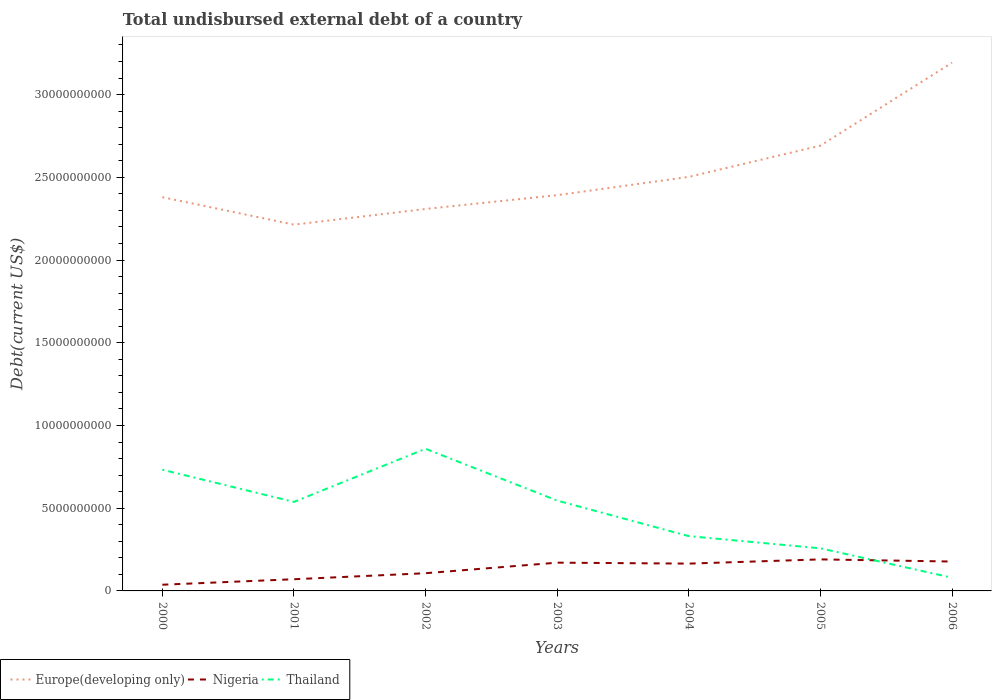Does the line corresponding to Nigeria intersect with the line corresponding to Europe(developing only)?
Your answer should be compact. No. Across all years, what is the maximum total undisbursed external debt in Thailand?
Your answer should be compact. 8.01e+08. In which year was the total undisbursed external debt in Nigeria maximum?
Your answer should be very brief. 2000. What is the total total undisbursed external debt in Nigeria in the graph?
Give a very brief answer. 1.30e+08. What is the difference between the highest and the second highest total undisbursed external debt in Nigeria?
Provide a succinct answer. 1.53e+09. How many years are there in the graph?
Offer a very short reply. 7. Are the values on the major ticks of Y-axis written in scientific E-notation?
Provide a succinct answer. No. Where does the legend appear in the graph?
Offer a very short reply. Bottom left. What is the title of the graph?
Ensure brevity in your answer.  Total undisbursed external debt of a country. What is the label or title of the X-axis?
Give a very brief answer. Years. What is the label or title of the Y-axis?
Your response must be concise. Debt(current US$). What is the Debt(current US$) in Europe(developing only) in 2000?
Provide a short and direct response. 2.38e+1. What is the Debt(current US$) of Nigeria in 2000?
Your response must be concise. 3.75e+08. What is the Debt(current US$) in Thailand in 2000?
Your answer should be very brief. 7.33e+09. What is the Debt(current US$) in Europe(developing only) in 2001?
Provide a succinct answer. 2.21e+1. What is the Debt(current US$) of Nigeria in 2001?
Ensure brevity in your answer.  7.07e+08. What is the Debt(current US$) in Thailand in 2001?
Your answer should be compact. 5.38e+09. What is the Debt(current US$) of Europe(developing only) in 2002?
Your answer should be compact. 2.31e+1. What is the Debt(current US$) in Nigeria in 2002?
Provide a succinct answer. 1.07e+09. What is the Debt(current US$) of Thailand in 2002?
Give a very brief answer. 8.59e+09. What is the Debt(current US$) in Europe(developing only) in 2003?
Ensure brevity in your answer.  2.39e+1. What is the Debt(current US$) in Nigeria in 2003?
Keep it short and to the point. 1.71e+09. What is the Debt(current US$) in Thailand in 2003?
Offer a terse response. 5.46e+09. What is the Debt(current US$) of Europe(developing only) in 2004?
Provide a succinct answer. 2.50e+1. What is the Debt(current US$) in Nigeria in 2004?
Provide a succinct answer. 1.65e+09. What is the Debt(current US$) of Thailand in 2004?
Offer a very short reply. 3.31e+09. What is the Debt(current US$) of Europe(developing only) in 2005?
Offer a very short reply. 2.69e+1. What is the Debt(current US$) in Nigeria in 2005?
Your answer should be very brief. 1.91e+09. What is the Debt(current US$) of Thailand in 2005?
Ensure brevity in your answer.  2.58e+09. What is the Debt(current US$) of Europe(developing only) in 2006?
Provide a succinct answer. 3.19e+1. What is the Debt(current US$) in Nigeria in 2006?
Provide a succinct answer. 1.78e+09. What is the Debt(current US$) in Thailand in 2006?
Provide a short and direct response. 8.01e+08. Across all years, what is the maximum Debt(current US$) in Europe(developing only)?
Your answer should be very brief. 3.19e+1. Across all years, what is the maximum Debt(current US$) in Nigeria?
Give a very brief answer. 1.91e+09. Across all years, what is the maximum Debt(current US$) of Thailand?
Your answer should be very brief. 8.59e+09. Across all years, what is the minimum Debt(current US$) in Europe(developing only)?
Give a very brief answer. 2.21e+1. Across all years, what is the minimum Debt(current US$) of Nigeria?
Keep it short and to the point. 3.75e+08. Across all years, what is the minimum Debt(current US$) in Thailand?
Your answer should be compact. 8.01e+08. What is the total Debt(current US$) of Europe(developing only) in the graph?
Your answer should be compact. 1.77e+11. What is the total Debt(current US$) of Nigeria in the graph?
Ensure brevity in your answer.  9.19e+09. What is the total Debt(current US$) of Thailand in the graph?
Make the answer very short. 3.34e+1. What is the difference between the Debt(current US$) of Europe(developing only) in 2000 and that in 2001?
Provide a short and direct response. 1.66e+09. What is the difference between the Debt(current US$) in Nigeria in 2000 and that in 2001?
Ensure brevity in your answer.  -3.31e+08. What is the difference between the Debt(current US$) of Thailand in 2000 and that in 2001?
Provide a short and direct response. 1.94e+09. What is the difference between the Debt(current US$) of Europe(developing only) in 2000 and that in 2002?
Ensure brevity in your answer.  7.11e+08. What is the difference between the Debt(current US$) of Nigeria in 2000 and that in 2002?
Offer a very short reply. -6.95e+08. What is the difference between the Debt(current US$) of Thailand in 2000 and that in 2002?
Keep it short and to the point. -1.27e+09. What is the difference between the Debt(current US$) in Europe(developing only) in 2000 and that in 2003?
Keep it short and to the point. -1.23e+08. What is the difference between the Debt(current US$) in Nigeria in 2000 and that in 2003?
Provide a short and direct response. -1.33e+09. What is the difference between the Debt(current US$) of Thailand in 2000 and that in 2003?
Give a very brief answer. 1.86e+09. What is the difference between the Debt(current US$) of Europe(developing only) in 2000 and that in 2004?
Ensure brevity in your answer.  -1.23e+09. What is the difference between the Debt(current US$) in Nigeria in 2000 and that in 2004?
Provide a short and direct response. -1.28e+09. What is the difference between the Debt(current US$) of Thailand in 2000 and that in 2004?
Give a very brief answer. 4.01e+09. What is the difference between the Debt(current US$) of Europe(developing only) in 2000 and that in 2005?
Provide a short and direct response. -3.12e+09. What is the difference between the Debt(current US$) in Nigeria in 2000 and that in 2005?
Give a very brief answer. -1.53e+09. What is the difference between the Debt(current US$) in Thailand in 2000 and that in 2005?
Provide a short and direct response. 4.75e+09. What is the difference between the Debt(current US$) in Europe(developing only) in 2000 and that in 2006?
Give a very brief answer. -8.13e+09. What is the difference between the Debt(current US$) of Nigeria in 2000 and that in 2006?
Your response must be concise. -1.40e+09. What is the difference between the Debt(current US$) in Thailand in 2000 and that in 2006?
Your response must be concise. 6.52e+09. What is the difference between the Debt(current US$) of Europe(developing only) in 2001 and that in 2002?
Your answer should be very brief. -9.48e+08. What is the difference between the Debt(current US$) in Nigeria in 2001 and that in 2002?
Give a very brief answer. -3.63e+08. What is the difference between the Debt(current US$) of Thailand in 2001 and that in 2002?
Ensure brevity in your answer.  -3.21e+09. What is the difference between the Debt(current US$) of Europe(developing only) in 2001 and that in 2003?
Offer a terse response. -1.78e+09. What is the difference between the Debt(current US$) of Nigeria in 2001 and that in 2003?
Give a very brief answer. -1.00e+09. What is the difference between the Debt(current US$) in Thailand in 2001 and that in 2003?
Ensure brevity in your answer.  -7.97e+07. What is the difference between the Debt(current US$) in Europe(developing only) in 2001 and that in 2004?
Your answer should be very brief. -2.89e+09. What is the difference between the Debt(current US$) in Nigeria in 2001 and that in 2004?
Give a very brief answer. -9.45e+08. What is the difference between the Debt(current US$) in Thailand in 2001 and that in 2004?
Make the answer very short. 2.07e+09. What is the difference between the Debt(current US$) in Europe(developing only) in 2001 and that in 2005?
Give a very brief answer. -4.77e+09. What is the difference between the Debt(current US$) in Nigeria in 2001 and that in 2005?
Offer a terse response. -1.20e+09. What is the difference between the Debt(current US$) in Thailand in 2001 and that in 2005?
Give a very brief answer. 2.81e+09. What is the difference between the Debt(current US$) in Europe(developing only) in 2001 and that in 2006?
Your answer should be compact. -9.79e+09. What is the difference between the Debt(current US$) of Nigeria in 2001 and that in 2006?
Your response must be concise. -1.07e+09. What is the difference between the Debt(current US$) in Thailand in 2001 and that in 2006?
Your response must be concise. 4.58e+09. What is the difference between the Debt(current US$) of Europe(developing only) in 2002 and that in 2003?
Provide a succinct answer. -8.34e+08. What is the difference between the Debt(current US$) in Nigeria in 2002 and that in 2003?
Offer a very short reply. -6.38e+08. What is the difference between the Debt(current US$) in Thailand in 2002 and that in 2003?
Ensure brevity in your answer.  3.13e+09. What is the difference between the Debt(current US$) in Europe(developing only) in 2002 and that in 2004?
Provide a short and direct response. -1.94e+09. What is the difference between the Debt(current US$) in Nigeria in 2002 and that in 2004?
Your response must be concise. -5.81e+08. What is the difference between the Debt(current US$) in Thailand in 2002 and that in 2004?
Provide a short and direct response. 5.28e+09. What is the difference between the Debt(current US$) of Europe(developing only) in 2002 and that in 2005?
Keep it short and to the point. -3.83e+09. What is the difference between the Debt(current US$) in Nigeria in 2002 and that in 2005?
Keep it short and to the point. -8.36e+08. What is the difference between the Debt(current US$) in Thailand in 2002 and that in 2005?
Keep it short and to the point. 6.02e+09. What is the difference between the Debt(current US$) of Europe(developing only) in 2002 and that in 2006?
Your response must be concise. -8.84e+09. What is the difference between the Debt(current US$) in Nigeria in 2002 and that in 2006?
Provide a succinct answer. -7.06e+08. What is the difference between the Debt(current US$) of Thailand in 2002 and that in 2006?
Offer a very short reply. 7.79e+09. What is the difference between the Debt(current US$) in Europe(developing only) in 2003 and that in 2004?
Ensure brevity in your answer.  -1.10e+09. What is the difference between the Debt(current US$) in Nigeria in 2003 and that in 2004?
Ensure brevity in your answer.  5.67e+07. What is the difference between the Debt(current US$) of Thailand in 2003 and that in 2004?
Give a very brief answer. 2.15e+09. What is the difference between the Debt(current US$) in Europe(developing only) in 2003 and that in 2005?
Keep it short and to the point. -2.99e+09. What is the difference between the Debt(current US$) of Nigeria in 2003 and that in 2005?
Your answer should be very brief. -1.98e+08. What is the difference between the Debt(current US$) of Thailand in 2003 and that in 2005?
Provide a short and direct response. 2.88e+09. What is the difference between the Debt(current US$) of Europe(developing only) in 2003 and that in 2006?
Your response must be concise. -8.01e+09. What is the difference between the Debt(current US$) of Nigeria in 2003 and that in 2006?
Offer a very short reply. -6.82e+07. What is the difference between the Debt(current US$) of Thailand in 2003 and that in 2006?
Offer a very short reply. 4.66e+09. What is the difference between the Debt(current US$) of Europe(developing only) in 2004 and that in 2005?
Make the answer very short. -1.89e+09. What is the difference between the Debt(current US$) in Nigeria in 2004 and that in 2005?
Give a very brief answer. -2.55e+08. What is the difference between the Debt(current US$) in Thailand in 2004 and that in 2005?
Keep it short and to the point. 7.36e+08. What is the difference between the Debt(current US$) of Europe(developing only) in 2004 and that in 2006?
Provide a short and direct response. -6.90e+09. What is the difference between the Debt(current US$) in Nigeria in 2004 and that in 2006?
Your answer should be very brief. -1.25e+08. What is the difference between the Debt(current US$) of Thailand in 2004 and that in 2006?
Ensure brevity in your answer.  2.51e+09. What is the difference between the Debt(current US$) of Europe(developing only) in 2005 and that in 2006?
Offer a terse response. -5.01e+09. What is the difference between the Debt(current US$) of Nigeria in 2005 and that in 2006?
Make the answer very short. 1.30e+08. What is the difference between the Debt(current US$) in Thailand in 2005 and that in 2006?
Provide a short and direct response. 1.78e+09. What is the difference between the Debt(current US$) in Europe(developing only) in 2000 and the Debt(current US$) in Nigeria in 2001?
Ensure brevity in your answer.  2.31e+1. What is the difference between the Debt(current US$) of Europe(developing only) in 2000 and the Debt(current US$) of Thailand in 2001?
Keep it short and to the point. 1.84e+1. What is the difference between the Debt(current US$) in Nigeria in 2000 and the Debt(current US$) in Thailand in 2001?
Provide a short and direct response. -5.01e+09. What is the difference between the Debt(current US$) in Europe(developing only) in 2000 and the Debt(current US$) in Nigeria in 2002?
Provide a succinct answer. 2.27e+1. What is the difference between the Debt(current US$) of Europe(developing only) in 2000 and the Debt(current US$) of Thailand in 2002?
Keep it short and to the point. 1.52e+1. What is the difference between the Debt(current US$) of Nigeria in 2000 and the Debt(current US$) of Thailand in 2002?
Your answer should be compact. -8.22e+09. What is the difference between the Debt(current US$) of Europe(developing only) in 2000 and the Debt(current US$) of Nigeria in 2003?
Your answer should be very brief. 2.21e+1. What is the difference between the Debt(current US$) of Europe(developing only) in 2000 and the Debt(current US$) of Thailand in 2003?
Your answer should be compact. 1.83e+1. What is the difference between the Debt(current US$) in Nigeria in 2000 and the Debt(current US$) in Thailand in 2003?
Ensure brevity in your answer.  -5.09e+09. What is the difference between the Debt(current US$) in Europe(developing only) in 2000 and the Debt(current US$) in Nigeria in 2004?
Give a very brief answer. 2.21e+1. What is the difference between the Debt(current US$) in Europe(developing only) in 2000 and the Debt(current US$) in Thailand in 2004?
Your answer should be very brief. 2.05e+1. What is the difference between the Debt(current US$) of Nigeria in 2000 and the Debt(current US$) of Thailand in 2004?
Provide a short and direct response. -2.94e+09. What is the difference between the Debt(current US$) in Europe(developing only) in 2000 and the Debt(current US$) in Nigeria in 2005?
Give a very brief answer. 2.19e+1. What is the difference between the Debt(current US$) of Europe(developing only) in 2000 and the Debt(current US$) of Thailand in 2005?
Offer a very short reply. 2.12e+1. What is the difference between the Debt(current US$) of Nigeria in 2000 and the Debt(current US$) of Thailand in 2005?
Your answer should be compact. -2.20e+09. What is the difference between the Debt(current US$) in Europe(developing only) in 2000 and the Debt(current US$) in Nigeria in 2006?
Keep it short and to the point. 2.20e+1. What is the difference between the Debt(current US$) in Europe(developing only) in 2000 and the Debt(current US$) in Thailand in 2006?
Keep it short and to the point. 2.30e+1. What is the difference between the Debt(current US$) of Nigeria in 2000 and the Debt(current US$) of Thailand in 2006?
Provide a succinct answer. -4.25e+08. What is the difference between the Debt(current US$) in Europe(developing only) in 2001 and the Debt(current US$) in Nigeria in 2002?
Give a very brief answer. 2.11e+1. What is the difference between the Debt(current US$) in Europe(developing only) in 2001 and the Debt(current US$) in Thailand in 2002?
Offer a terse response. 1.35e+1. What is the difference between the Debt(current US$) in Nigeria in 2001 and the Debt(current US$) in Thailand in 2002?
Your response must be concise. -7.88e+09. What is the difference between the Debt(current US$) of Europe(developing only) in 2001 and the Debt(current US$) of Nigeria in 2003?
Give a very brief answer. 2.04e+1. What is the difference between the Debt(current US$) of Europe(developing only) in 2001 and the Debt(current US$) of Thailand in 2003?
Your response must be concise. 1.67e+1. What is the difference between the Debt(current US$) in Nigeria in 2001 and the Debt(current US$) in Thailand in 2003?
Your answer should be compact. -4.75e+09. What is the difference between the Debt(current US$) in Europe(developing only) in 2001 and the Debt(current US$) in Nigeria in 2004?
Your response must be concise. 2.05e+1. What is the difference between the Debt(current US$) of Europe(developing only) in 2001 and the Debt(current US$) of Thailand in 2004?
Offer a terse response. 1.88e+1. What is the difference between the Debt(current US$) in Nigeria in 2001 and the Debt(current US$) in Thailand in 2004?
Offer a terse response. -2.61e+09. What is the difference between the Debt(current US$) of Europe(developing only) in 2001 and the Debt(current US$) of Nigeria in 2005?
Offer a very short reply. 2.02e+1. What is the difference between the Debt(current US$) in Europe(developing only) in 2001 and the Debt(current US$) in Thailand in 2005?
Make the answer very short. 1.96e+1. What is the difference between the Debt(current US$) of Nigeria in 2001 and the Debt(current US$) of Thailand in 2005?
Offer a very short reply. -1.87e+09. What is the difference between the Debt(current US$) in Europe(developing only) in 2001 and the Debt(current US$) in Nigeria in 2006?
Keep it short and to the point. 2.04e+1. What is the difference between the Debt(current US$) of Europe(developing only) in 2001 and the Debt(current US$) of Thailand in 2006?
Keep it short and to the point. 2.13e+1. What is the difference between the Debt(current US$) of Nigeria in 2001 and the Debt(current US$) of Thailand in 2006?
Provide a short and direct response. -9.40e+07. What is the difference between the Debt(current US$) of Europe(developing only) in 2002 and the Debt(current US$) of Nigeria in 2003?
Make the answer very short. 2.14e+1. What is the difference between the Debt(current US$) of Europe(developing only) in 2002 and the Debt(current US$) of Thailand in 2003?
Your answer should be compact. 1.76e+1. What is the difference between the Debt(current US$) in Nigeria in 2002 and the Debt(current US$) in Thailand in 2003?
Give a very brief answer. -4.39e+09. What is the difference between the Debt(current US$) in Europe(developing only) in 2002 and the Debt(current US$) in Nigeria in 2004?
Your answer should be compact. 2.14e+1. What is the difference between the Debt(current US$) of Europe(developing only) in 2002 and the Debt(current US$) of Thailand in 2004?
Keep it short and to the point. 1.98e+1. What is the difference between the Debt(current US$) of Nigeria in 2002 and the Debt(current US$) of Thailand in 2004?
Provide a short and direct response. -2.24e+09. What is the difference between the Debt(current US$) in Europe(developing only) in 2002 and the Debt(current US$) in Nigeria in 2005?
Your response must be concise. 2.12e+1. What is the difference between the Debt(current US$) in Europe(developing only) in 2002 and the Debt(current US$) in Thailand in 2005?
Keep it short and to the point. 2.05e+1. What is the difference between the Debt(current US$) of Nigeria in 2002 and the Debt(current US$) of Thailand in 2005?
Offer a terse response. -1.51e+09. What is the difference between the Debt(current US$) in Europe(developing only) in 2002 and the Debt(current US$) in Nigeria in 2006?
Your response must be concise. 2.13e+1. What is the difference between the Debt(current US$) of Europe(developing only) in 2002 and the Debt(current US$) of Thailand in 2006?
Provide a short and direct response. 2.23e+1. What is the difference between the Debt(current US$) in Nigeria in 2002 and the Debt(current US$) in Thailand in 2006?
Ensure brevity in your answer.  2.69e+08. What is the difference between the Debt(current US$) of Europe(developing only) in 2003 and the Debt(current US$) of Nigeria in 2004?
Provide a short and direct response. 2.23e+1. What is the difference between the Debt(current US$) of Europe(developing only) in 2003 and the Debt(current US$) of Thailand in 2004?
Offer a terse response. 2.06e+1. What is the difference between the Debt(current US$) in Nigeria in 2003 and the Debt(current US$) in Thailand in 2004?
Ensure brevity in your answer.  -1.60e+09. What is the difference between the Debt(current US$) of Europe(developing only) in 2003 and the Debt(current US$) of Nigeria in 2005?
Keep it short and to the point. 2.20e+1. What is the difference between the Debt(current US$) in Europe(developing only) in 2003 and the Debt(current US$) in Thailand in 2005?
Your answer should be compact. 2.13e+1. What is the difference between the Debt(current US$) in Nigeria in 2003 and the Debt(current US$) in Thailand in 2005?
Provide a succinct answer. -8.68e+08. What is the difference between the Debt(current US$) of Europe(developing only) in 2003 and the Debt(current US$) of Nigeria in 2006?
Make the answer very short. 2.21e+1. What is the difference between the Debt(current US$) of Europe(developing only) in 2003 and the Debt(current US$) of Thailand in 2006?
Provide a succinct answer. 2.31e+1. What is the difference between the Debt(current US$) of Nigeria in 2003 and the Debt(current US$) of Thailand in 2006?
Give a very brief answer. 9.07e+08. What is the difference between the Debt(current US$) in Europe(developing only) in 2004 and the Debt(current US$) in Nigeria in 2005?
Provide a short and direct response. 2.31e+1. What is the difference between the Debt(current US$) of Europe(developing only) in 2004 and the Debt(current US$) of Thailand in 2005?
Make the answer very short. 2.24e+1. What is the difference between the Debt(current US$) in Nigeria in 2004 and the Debt(current US$) in Thailand in 2005?
Provide a succinct answer. -9.25e+08. What is the difference between the Debt(current US$) in Europe(developing only) in 2004 and the Debt(current US$) in Nigeria in 2006?
Your answer should be compact. 2.32e+1. What is the difference between the Debt(current US$) in Europe(developing only) in 2004 and the Debt(current US$) in Thailand in 2006?
Provide a succinct answer. 2.42e+1. What is the difference between the Debt(current US$) of Nigeria in 2004 and the Debt(current US$) of Thailand in 2006?
Offer a very short reply. 8.51e+08. What is the difference between the Debt(current US$) of Europe(developing only) in 2005 and the Debt(current US$) of Nigeria in 2006?
Ensure brevity in your answer.  2.51e+1. What is the difference between the Debt(current US$) in Europe(developing only) in 2005 and the Debt(current US$) in Thailand in 2006?
Your answer should be compact. 2.61e+1. What is the difference between the Debt(current US$) in Nigeria in 2005 and the Debt(current US$) in Thailand in 2006?
Provide a short and direct response. 1.11e+09. What is the average Debt(current US$) of Europe(developing only) per year?
Your response must be concise. 2.53e+1. What is the average Debt(current US$) of Nigeria per year?
Make the answer very short. 1.31e+09. What is the average Debt(current US$) of Thailand per year?
Offer a terse response. 4.78e+09. In the year 2000, what is the difference between the Debt(current US$) in Europe(developing only) and Debt(current US$) in Nigeria?
Offer a very short reply. 2.34e+1. In the year 2000, what is the difference between the Debt(current US$) of Europe(developing only) and Debt(current US$) of Thailand?
Your answer should be compact. 1.65e+1. In the year 2000, what is the difference between the Debt(current US$) of Nigeria and Debt(current US$) of Thailand?
Offer a very short reply. -6.95e+09. In the year 2001, what is the difference between the Debt(current US$) of Europe(developing only) and Debt(current US$) of Nigeria?
Offer a terse response. 2.14e+1. In the year 2001, what is the difference between the Debt(current US$) of Europe(developing only) and Debt(current US$) of Thailand?
Your answer should be compact. 1.68e+1. In the year 2001, what is the difference between the Debt(current US$) of Nigeria and Debt(current US$) of Thailand?
Give a very brief answer. -4.67e+09. In the year 2002, what is the difference between the Debt(current US$) in Europe(developing only) and Debt(current US$) in Nigeria?
Keep it short and to the point. 2.20e+1. In the year 2002, what is the difference between the Debt(current US$) in Europe(developing only) and Debt(current US$) in Thailand?
Provide a short and direct response. 1.45e+1. In the year 2002, what is the difference between the Debt(current US$) in Nigeria and Debt(current US$) in Thailand?
Offer a terse response. -7.52e+09. In the year 2003, what is the difference between the Debt(current US$) of Europe(developing only) and Debt(current US$) of Nigeria?
Your answer should be very brief. 2.22e+1. In the year 2003, what is the difference between the Debt(current US$) of Europe(developing only) and Debt(current US$) of Thailand?
Make the answer very short. 1.85e+1. In the year 2003, what is the difference between the Debt(current US$) in Nigeria and Debt(current US$) in Thailand?
Provide a succinct answer. -3.75e+09. In the year 2004, what is the difference between the Debt(current US$) of Europe(developing only) and Debt(current US$) of Nigeria?
Your response must be concise. 2.34e+1. In the year 2004, what is the difference between the Debt(current US$) of Europe(developing only) and Debt(current US$) of Thailand?
Provide a short and direct response. 2.17e+1. In the year 2004, what is the difference between the Debt(current US$) in Nigeria and Debt(current US$) in Thailand?
Your response must be concise. -1.66e+09. In the year 2005, what is the difference between the Debt(current US$) of Europe(developing only) and Debt(current US$) of Nigeria?
Provide a succinct answer. 2.50e+1. In the year 2005, what is the difference between the Debt(current US$) of Europe(developing only) and Debt(current US$) of Thailand?
Your answer should be compact. 2.43e+1. In the year 2005, what is the difference between the Debt(current US$) of Nigeria and Debt(current US$) of Thailand?
Provide a succinct answer. -6.70e+08. In the year 2006, what is the difference between the Debt(current US$) in Europe(developing only) and Debt(current US$) in Nigeria?
Your response must be concise. 3.02e+1. In the year 2006, what is the difference between the Debt(current US$) in Europe(developing only) and Debt(current US$) in Thailand?
Your response must be concise. 3.11e+1. In the year 2006, what is the difference between the Debt(current US$) in Nigeria and Debt(current US$) in Thailand?
Ensure brevity in your answer.  9.75e+08. What is the ratio of the Debt(current US$) of Europe(developing only) in 2000 to that in 2001?
Offer a very short reply. 1.07. What is the ratio of the Debt(current US$) in Nigeria in 2000 to that in 2001?
Your answer should be very brief. 0.53. What is the ratio of the Debt(current US$) of Thailand in 2000 to that in 2001?
Make the answer very short. 1.36. What is the ratio of the Debt(current US$) of Europe(developing only) in 2000 to that in 2002?
Provide a succinct answer. 1.03. What is the ratio of the Debt(current US$) of Nigeria in 2000 to that in 2002?
Give a very brief answer. 0.35. What is the ratio of the Debt(current US$) in Thailand in 2000 to that in 2002?
Make the answer very short. 0.85. What is the ratio of the Debt(current US$) in Nigeria in 2000 to that in 2003?
Provide a succinct answer. 0.22. What is the ratio of the Debt(current US$) in Thailand in 2000 to that in 2003?
Make the answer very short. 1.34. What is the ratio of the Debt(current US$) in Europe(developing only) in 2000 to that in 2004?
Ensure brevity in your answer.  0.95. What is the ratio of the Debt(current US$) in Nigeria in 2000 to that in 2004?
Your answer should be very brief. 0.23. What is the ratio of the Debt(current US$) of Thailand in 2000 to that in 2004?
Ensure brevity in your answer.  2.21. What is the ratio of the Debt(current US$) in Europe(developing only) in 2000 to that in 2005?
Offer a very short reply. 0.88. What is the ratio of the Debt(current US$) of Nigeria in 2000 to that in 2005?
Provide a short and direct response. 0.2. What is the ratio of the Debt(current US$) of Thailand in 2000 to that in 2005?
Provide a succinct answer. 2.84. What is the ratio of the Debt(current US$) in Europe(developing only) in 2000 to that in 2006?
Your response must be concise. 0.75. What is the ratio of the Debt(current US$) in Nigeria in 2000 to that in 2006?
Your answer should be very brief. 0.21. What is the ratio of the Debt(current US$) in Thailand in 2000 to that in 2006?
Give a very brief answer. 9.15. What is the ratio of the Debt(current US$) in Europe(developing only) in 2001 to that in 2002?
Offer a very short reply. 0.96. What is the ratio of the Debt(current US$) in Nigeria in 2001 to that in 2002?
Your response must be concise. 0.66. What is the ratio of the Debt(current US$) in Thailand in 2001 to that in 2002?
Give a very brief answer. 0.63. What is the ratio of the Debt(current US$) in Europe(developing only) in 2001 to that in 2003?
Give a very brief answer. 0.93. What is the ratio of the Debt(current US$) in Nigeria in 2001 to that in 2003?
Your response must be concise. 0.41. What is the ratio of the Debt(current US$) of Thailand in 2001 to that in 2003?
Give a very brief answer. 0.99. What is the ratio of the Debt(current US$) in Europe(developing only) in 2001 to that in 2004?
Your answer should be compact. 0.88. What is the ratio of the Debt(current US$) of Nigeria in 2001 to that in 2004?
Offer a terse response. 0.43. What is the ratio of the Debt(current US$) in Thailand in 2001 to that in 2004?
Keep it short and to the point. 1.62. What is the ratio of the Debt(current US$) in Europe(developing only) in 2001 to that in 2005?
Give a very brief answer. 0.82. What is the ratio of the Debt(current US$) in Nigeria in 2001 to that in 2005?
Give a very brief answer. 0.37. What is the ratio of the Debt(current US$) of Thailand in 2001 to that in 2005?
Provide a short and direct response. 2.09. What is the ratio of the Debt(current US$) of Europe(developing only) in 2001 to that in 2006?
Make the answer very short. 0.69. What is the ratio of the Debt(current US$) of Nigeria in 2001 to that in 2006?
Your answer should be very brief. 0.4. What is the ratio of the Debt(current US$) in Thailand in 2001 to that in 2006?
Make the answer very short. 6.72. What is the ratio of the Debt(current US$) of Europe(developing only) in 2002 to that in 2003?
Ensure brevity in your answer.  0.97. What is the ratio of the Debt(current US$) in Nigeria in 2002 to that in 2003?
Offer a terse response. 0.63. What is the ratio of the Debt(current US$) of Thailand in 2002 to that in 2003?
Keep it short and to the point. 1.57. What is the ratio of the Debt(current US$) in Europe(developing only) in 2002 to that in 2004?
Your answer should be very brief. 0.92. What is the ratio of the Debt(current US$) of Nigeria in 2002 to that in 2004?
Ensure brevity in your answer.  0.65. What is the ratio of the Debt(current US$) in Thailand in 2002 to that in 2004?
Offer a very short reply. 2.59. What is the ratio of the Debt(current US$) in Europe(developing only) in 2002 to that in 2005?
Provide a short and direct response. 0.86. What is the ratio of the Debt(current US$) in Nigeria in 2002 to that in 2005?
Provide a short and direct response. 0.56. What is the ratio of the Debt(current US$) in Thailand in 2002 to that in 2005?
Make the answer very short. 3.34. What is the ratio of the Debt(current US$) in Europe(developing only) in 2002 to that in 2006?
Offer a very short reply. 0.72. What is the ratio of the Debt(current US$) of Nigeria in 2002 to that in 2006?
Your response must be concise. 0.6. What is the ratio of the Debt(current US$) in Thailand in 2002 to that in 2006?
Offer a terse response. 10.73. What is the ratio of the Debt(current US$) of Europe(developing only) in 2003 to that in 2004?
Your answer should be compact. 0.96. What is the ratio of the Debt(current US$) in Nigeria in 2003 to that in 2004?
Your response must be concise. 1.03. What is the ratio of the Debt(current US$) in Thailand in 2003 to that in 2004?
Your answer should be very brief. 1.65. What is the ratio of the Debt(current US$) in Europe(developing only) in 2003 to that in 2005?
Keep it short and to the point. 0.89. What is the ratio of the Debt(current US$) in Nigeria in 2003 to that in 2005?
Offer a terse response. 0.9. What is the ratio of the Debt(current US$) in Thailand in 2003 to that in 2005?
Your answer should be very brief. 2.12. What is the ratio of the Debt(current US$) of Europe(developing only) in 2003 to that in 2006?
Ensure brevity in your answer.  0.75. What is the ratio of the Debt(current US$) of Nigeria in 2003 to that in 2006?
Your answer should be compact. 0.96. What is the ratio of the Debt(current US$) in Thailand in 2003 to that in 2006?
Offer a very short reply. 6.82. What is the ratio of the Debt(current US$) in Europe(developing only) in 2004 to that in 2005?
Keep it short and to the point. 0.93. What is the ratio of the Debt(current US$) of Nigeria in 2004 to that in 2005?
Provide a short and direct response. 0.87. What is the ratio of the Debt(current US$) of Thailand in 2004 to that in 2005?
Offer a very short reply. 1.29. What is the ratio of the Debt(current US$) in Europe(developing only) in 2004 to that in 2006?
Give a very brief answer. 0.78. What is the ratio of the Debt(current US$) in Nigeria in 2004 to that in 2006?
Keep it short and to the point. 0.93. What is the ratio of the Debt(current US$) of Thailand in 2004 to that in 2006?
Your response must be concise. 4.14. What is the ratio of the Debt(current US$) of Europe(developing only) in 2005 to that in 2006?
Offer a terse response. 0.84. What is the ratio of the Debt(current US$) in Nigeria in 2005 to that in 2006?
Ensure brevity in your answer.  1.07. What is the ratio of the Debt(current US$) of Thailand in 2005 to that in 2006?
Offer a very short reply. 3.22. What is the difference between the highest and the second highest Debt(current US$) in Europe(developing only)?
Ensure brevity in your answer.  5.01e+09. What is the difference between the highest and the second highest Debt(current US$) of Nigeria?
Your response must be concise. 1.30e+08. What is the difference between the highest and the second highest Debt(current US$) of Thailand?
Offer a terse response. 1.27e+09. What is the difference between the highest and the lowest Debt(current US$) of Europe(developing only)?
Provide a succinct answer. 9.79e+09. What is the difference between the highest and the lowest Debt(current US$) of Nigeria?
Your answer should be compact. 1.53e+09. What is the difference between the highest and the lowest Debt(current US$) in Thailand?
Your answer should be very brief. 7.79e+09. 